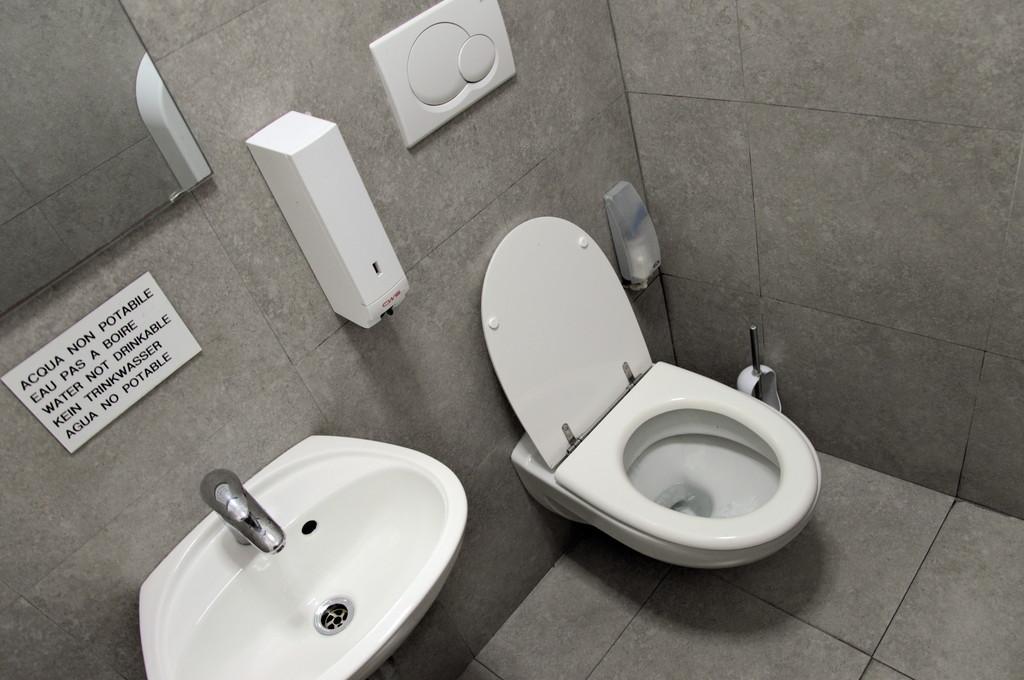Please provide a concise description of this image. Here in this picture we can see a western toilet and a sink with a tap on the wall over there and on the wall we can see a mirror and some other boxes also present over there. 